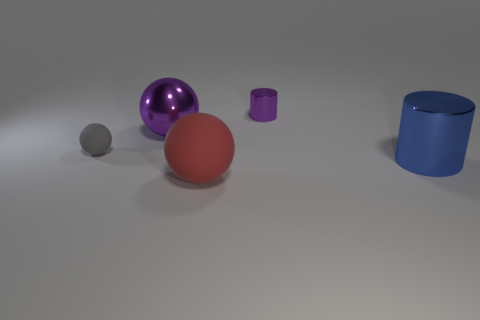The other shiny thing that is the same shape as the big red thing is what size?
Make the answer very short. Large. Is the color of the tiny shiny cylinder the same as the large shiny sphere?
Offer a very short reply. Yes. How many red objects are the same size as the blue thing?
Your answer should be compact. 1. Are there fewer big matte objects that are to the left of the big rubber ball than rubber balls behind the large cylinder?
Keep it short and to the point. Yes. What is the size of the cylinder in front of the purple shiny object that is behind the large object that is behind the small gray thing?
Offer a terse response. Large. How big is the metallic thing that is on the right side of the large rubber object and left of the blue object?
Offer a terse response. Small. There is a rubber object on the left side of the large metallic object that is to the left of the large red matte sphere; what is its shape?
Your response must be concise. Sphere. Is there any other thing of the same color as the small metallic thing?
Ensure brevity in your answer.  Yes. What shape is the shiny thing that is on the right side of the purple cylinder?
Offer a terse response. Cylinder. There is a big thing that is both in front of the big purple thing and left of the small metallic cylinder; what shape is it?
Ensure brevity in your answer.  Sphere. 